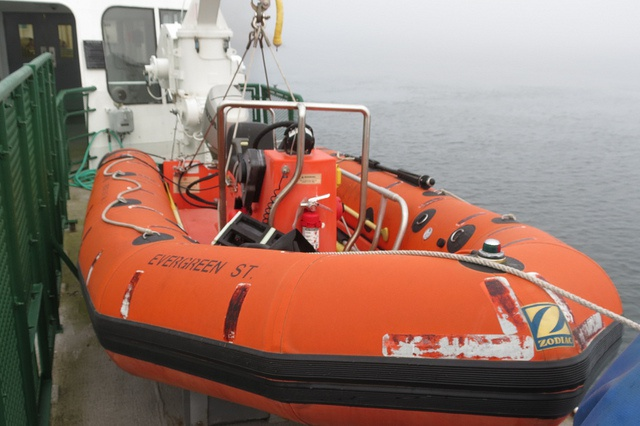Describe the objects in this image and their specific colors. I can see boat in gray, red, salmon, and black tones and boat in gray, lightgray, and darkgray tones in this image. 